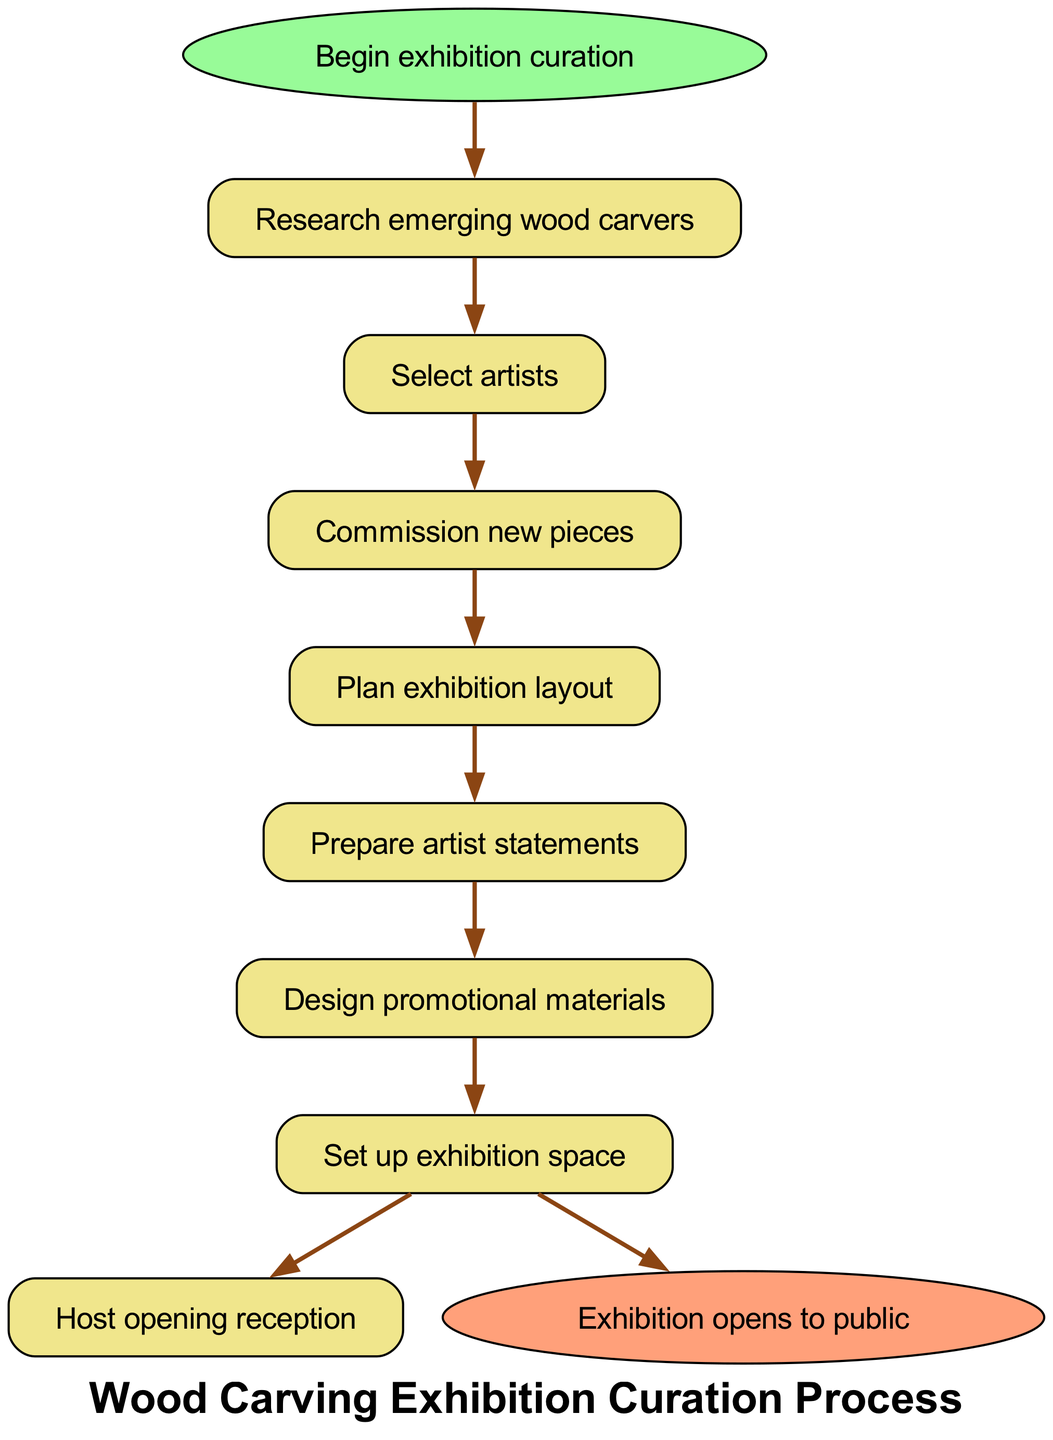What is the first step in the curation process? The first step in the flow chart is labeled "Research emerging wood carvers." This is the starting point from which the curation process begins.
Answer: Research emerging wood carvers How many steps are there in total? The diagram includes a total of 7 steps besides the start and end nodes. They progress sequentially from researching artists to hosting the reception.
Answer: 7 What is the last step before the exhibition opens? The last step before the exhibition opens is "Set up exhibition space." This is just before the node indicating the opening to the public, which is the end of the sequence.
Answer: Set up exhibition space What is the main task after "Select artists"? After "Select artists," the main task in the sequence is to "Commission new pieces." This is the next step that follows directly from selecting the artists.
Answer: Commission new pieces What is the relationship between “Design promotional materials” and “Prepare artist statements”? "Design promotional materials" is connected to "Prepare artist statements" as they both follow one another in the sequence of steps. First, artist statements are prepared, and then promotional materials are designed.
Answer: Sequential relationship What is the total number of edges in the diagram? Each step is connected to the next with one edge, and there are also edges connecting the start and end nodes to the sequence. Thus, the total number of edges equals the number of steps plus two (for start and end), which is 9.
Answer: 9 Which step involves the preparation of text for the exhibition? The step that involves preparation of text is "Prepare artist statements." This location in the flow chart underscores its significance as a critical informational task in exhibition preparation.
Answer: Prepare artist statements Which step directly follows “Plan exhibition layout”? The next step following "Plan exhibition layout" is "Prepare artist statements." This is identified by the direct connection from the layout planning to the preparation of the statements, indicating the sequence of tasks.
Answer: Prepare artist statements 